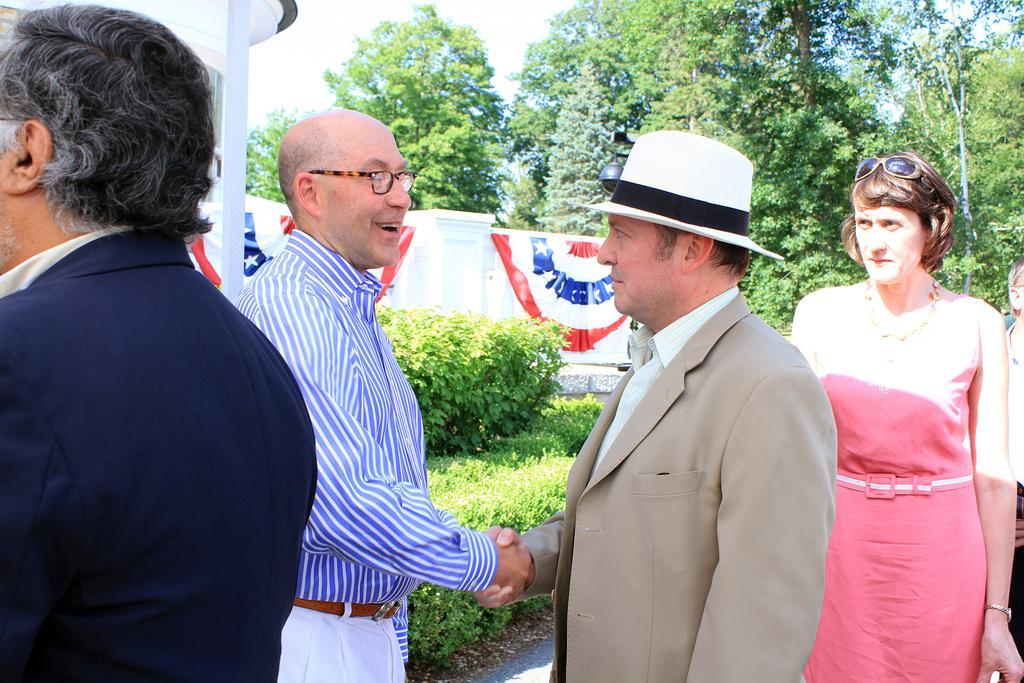Can you describe this image briefly? In the image there is a man with a hat on his head and he is standing. In front of him there is a man with spectacles and he is standing and shaking their hands. On the right side of the image there is a lady with goggles on her head. On the left corner of the image there is a man standing. Behind them there are bushes and trees. And also there is a wall with clothes and also there is a building. 